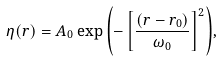<formula> <loc_0><loc_0><loc_500><loc_500>\eta ( r ) = A _ { 0 } \exp { \left ( - \left [ \frac { ( r - r _ { 0 } ) } { \omega _ { 0 } } \right ] ^ { 2 } \right ) } ,</formula> 